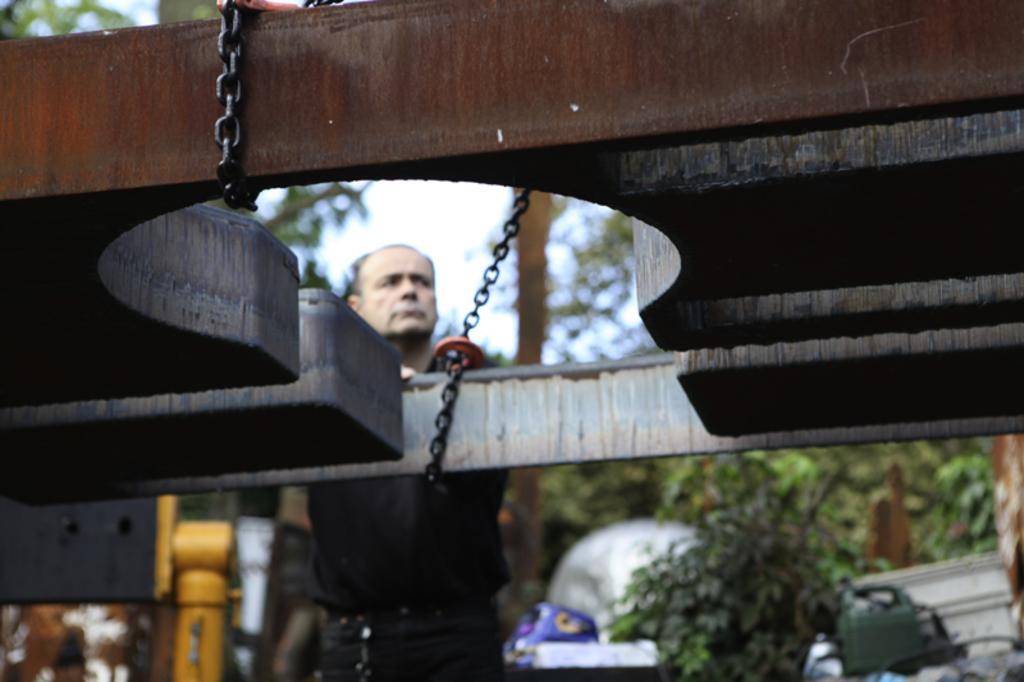How would you summarize this image in a sentence or two? In this picture we can see a metal object with chains, man standing, trees and some objects and in the background we can see the sky and it is blurry. 